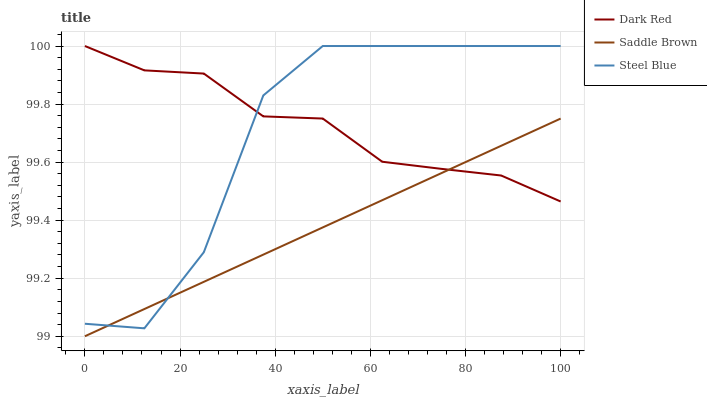Does Saddle Brown have the minimum area under the curve?
Answer yes or no. Yes. Does Dark Red have the maximum area under the curve?
Answer yes or no. Yes. Does Steel Blue have the minimum area under the curve?
Answer yes or no. No. Does Steel Blue have the maximum area under the curve?
Answer yes or no. No. Is Saddle Brown the smoothest?
Answer yes or no. Yes. Is Steel Blue the roughest?
Answer yes or no. Yes. Is Steel Blue the smoothest?
Answer yes or no. No. Is Saddle Brown the roughest?
Answer yes or no. No. Does Saddle Brown have the lowest value?
Answer yes or no. Yes. Does Steel Blue have the lowest value?
Answer yes or no. No. Does Steel Blue have the highest value?
Answer yes or no. Yes. Does Saddle Brown have the highest value?
Answer yes or no. No. Does Saddle Brown intersect Dark Red?
Answer yes or no. Yes. Is Saddle Brown less than Dark Red?
Answer yes or no. No. Is Saddle Brown greater than Dark Red?
Answer yes or no. No. 